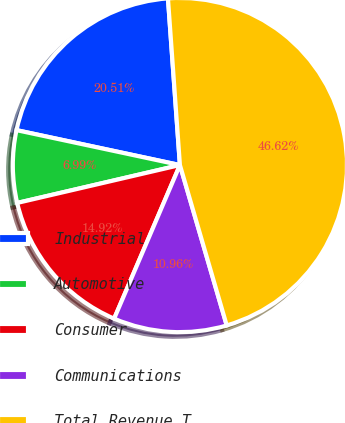<chart> <loc_0><loc_0><loc_500><loc_500><pie_chart><fcel>Industrial<fcel>Automotive<fcel>Consumer<fcel>Communications<fcel>Total Revenue T<nl><fcel>20.51%<fcel>6.99%<fcel>14.92%<fcel>10.96%<fcel>46.62%<nl></chart> 